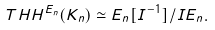<formula> <loc_0><loc_0><loc_500><loc_500>T H H ^ { E _ { n } } ( K _ { n } ) \simeq E _ { n } [ I ^ { - 1 } ] / I E _ { n } .</formula> 